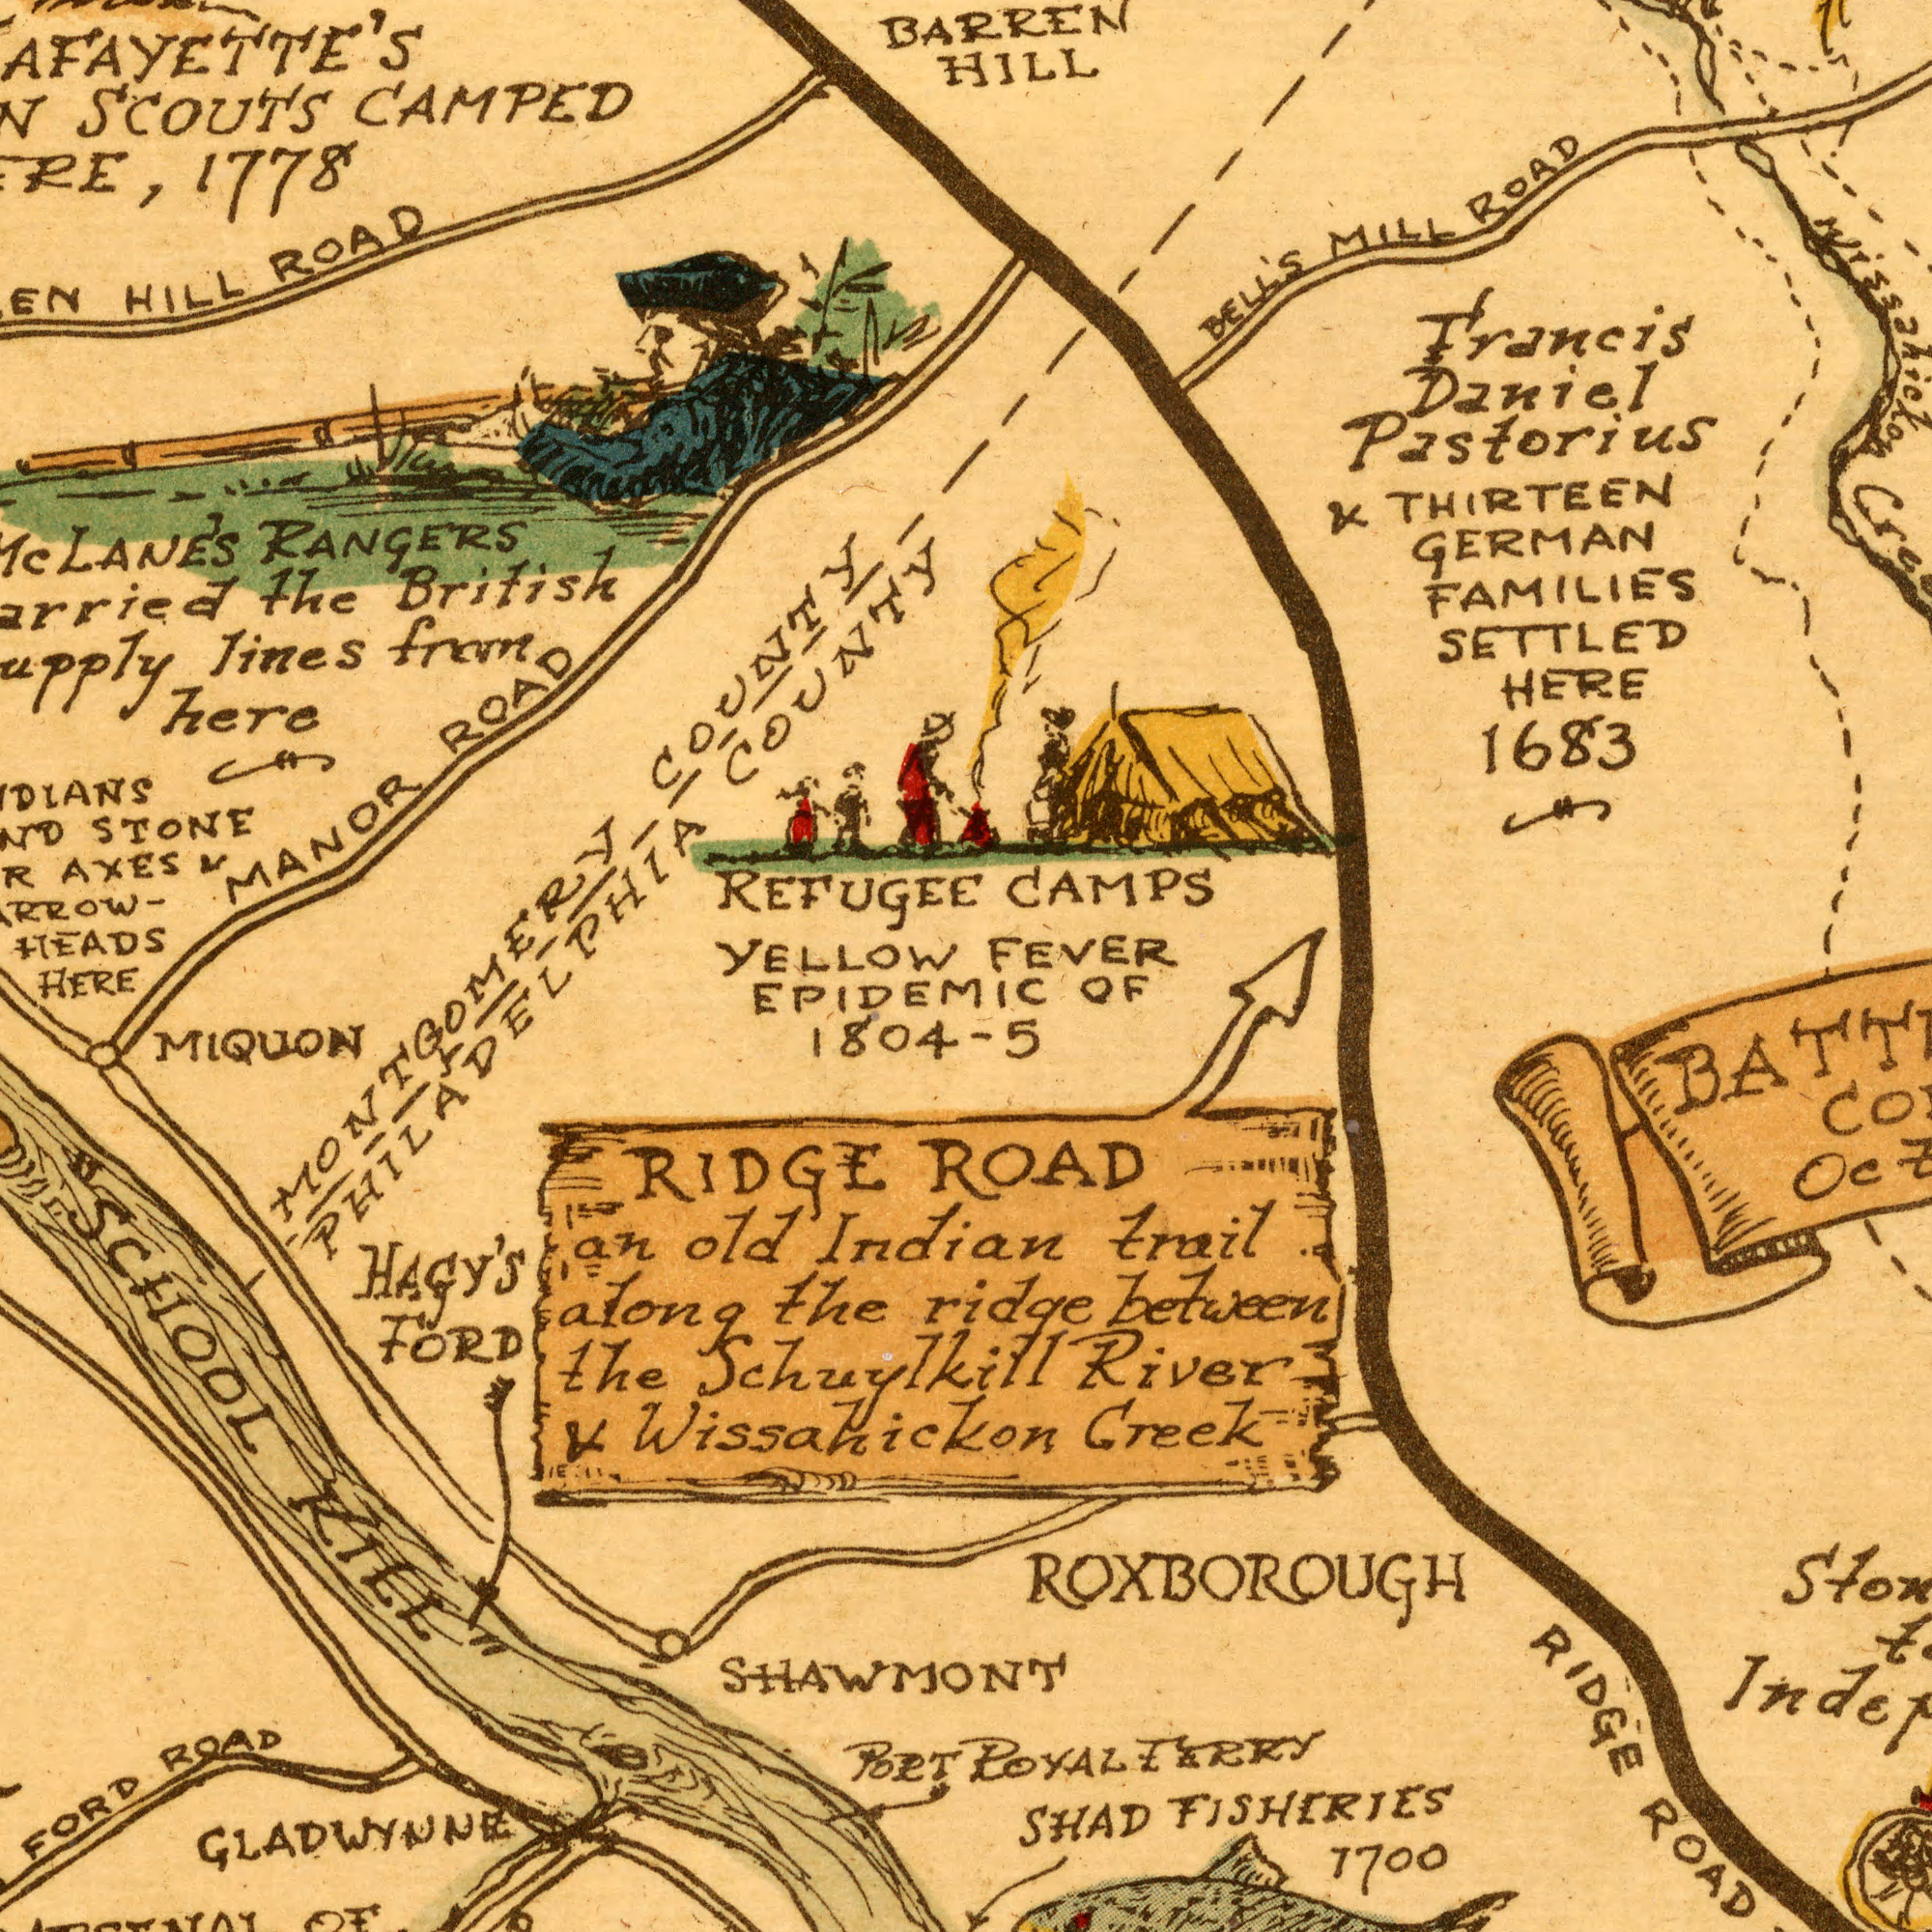What text can you see in the bottom-left section? FORD PORT FORD MIQUON the Indian SHAWMONT ROAD 1804-5 HAGY'S RIDGE HERE the old KILL" Wissahickon GLADWYNNE PHILADELPHIA Schuylkill MONTGOMERY an along "SCHOOL EPIDEMIC & OF What text can you see in the bottom-right section? ROAD Creek trail River Ind ROAD FISHERIES 1700 SHAD ROYAL FERRY between RIDGE OF ROXBOROUGH ridge & - 5 What text can you see in the top-right section? 1683 HILL FEVER Francis THIRTEEN Daniel HERE BELL'S BARREN SETTLED MILL ROAD CAMPS FAMILIES Pastorius GERMAN & Wissahicxon What text appears in the top-left area of the image? STONE HEADS CAMPED HILL the from here LANE'S RANGERS SCOUTS MANOR ROAD British lines AXES COUNTY ROAD COUNTY REFUGEE & YELLOW 1778 